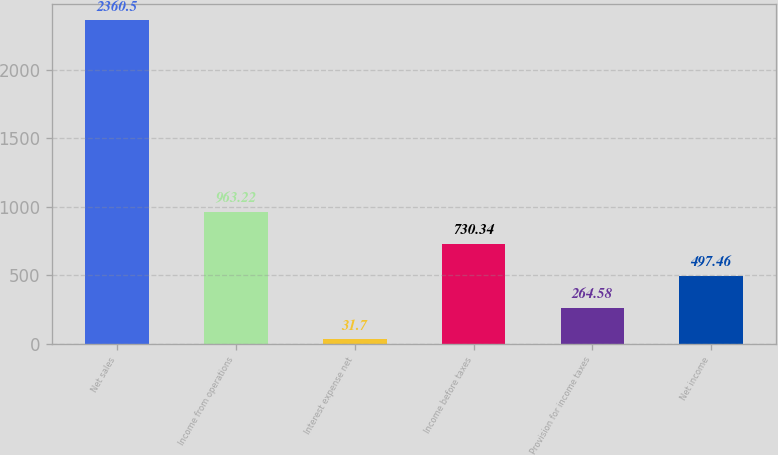Convert chart. <chart><loc_0><loc_0><loc_500><loc_500><bar_chart><fcel>Net sales<fcel>Income from operations<fcel>Interest expense net<fcel>Income before taxes<fcel>Provision for income taxes<fcel>Net income<nl><fcel>2360.5<fcel>963.22<fcel>31.7<fcel>730.34<fcel>264.58<fcel>497.46<nl></chart> 